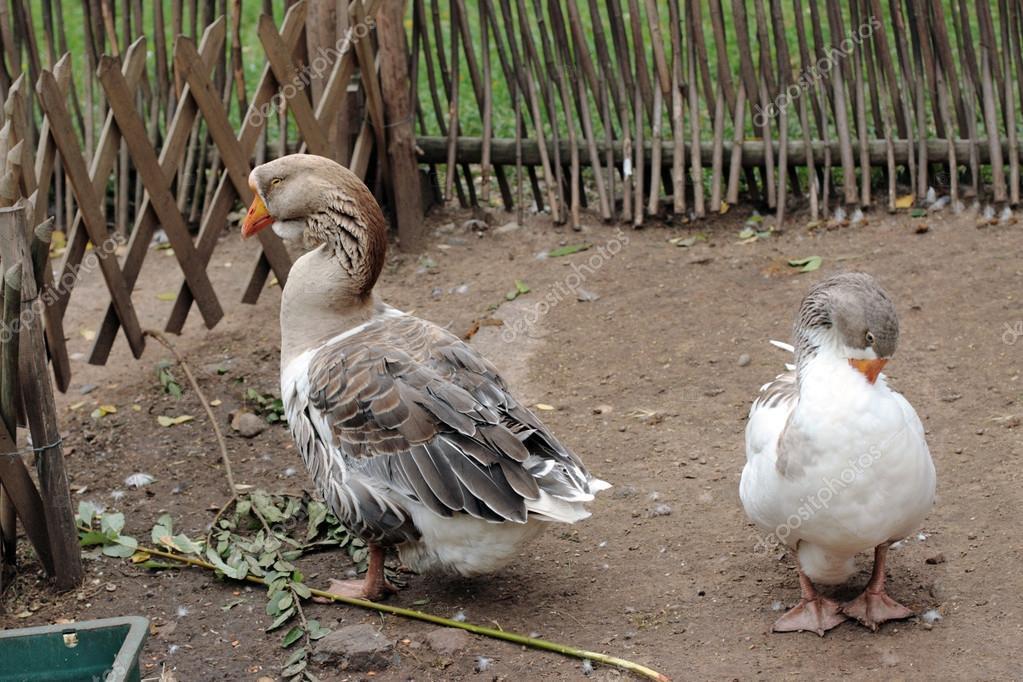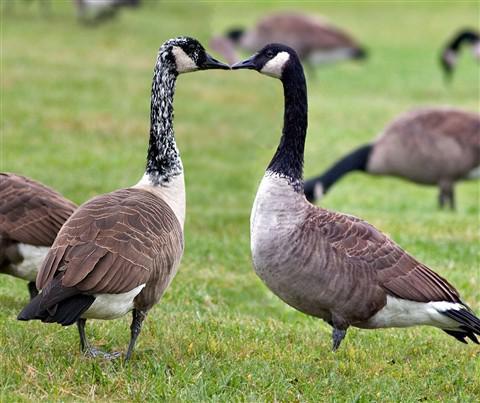The first image is the image on the left, the second image is the image on the right. Evaluate the accuracy of this statement regarding the images: "geese are facing each other and touching beaks". Is it true? Answer yes or no. Yes. The first image is the image on the left, the second image is the image on the right. Analyze the images presented: Is the assertion "There are two geese with their beaks pressed together in one of the images." valid? Answer yes or no. Yes. 